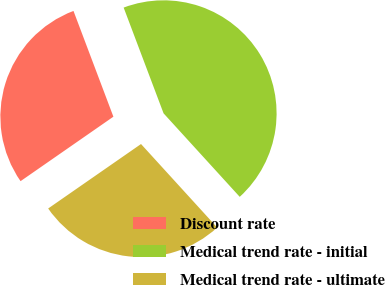Convert chart. <chart><loc_0><loc_0><loc_500><loc_500><pie_chart><fcel>Discount rate<fcel>Medical trend rate - initial<fcel>Medical trend rate - ultimate<nl><fcel>28.92%<fcel>43.98%<fcel>27.11%<nl></chart> 